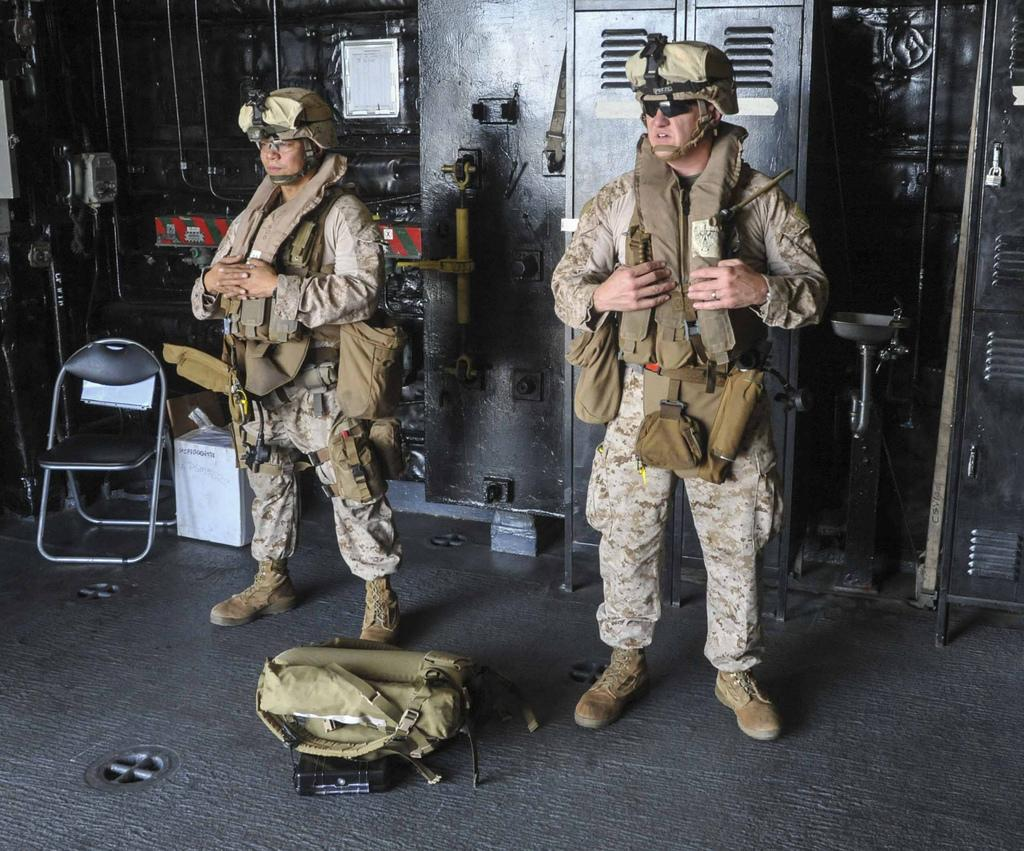How many soldiers are present in the image? There are two soldiers in the image. What are the soldiers doing in the image? The soldiers are standing. What is in front of the soldiers? There is a bag in front of the soldiers. What can be seen in the background of the image? There is a chair and other objects in the background of the image. What type of pie is being served on the chair in the background of the image? There is no pie present in the image; the chair and other objects in the background do not include a pie. 